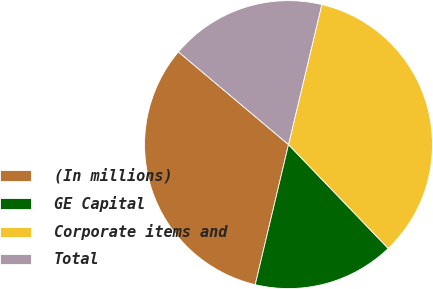<chart> <loc_0><loc_0><loc_500><loc_500><pie_chart><fcel>(In millions)<fcel>GE Capital<fcel>Corporate items and<fcel>Total<nl><fcel>32.43%<fcel>15.89%<fcel>34.11%<fcel>17.57%<nl></chart> 